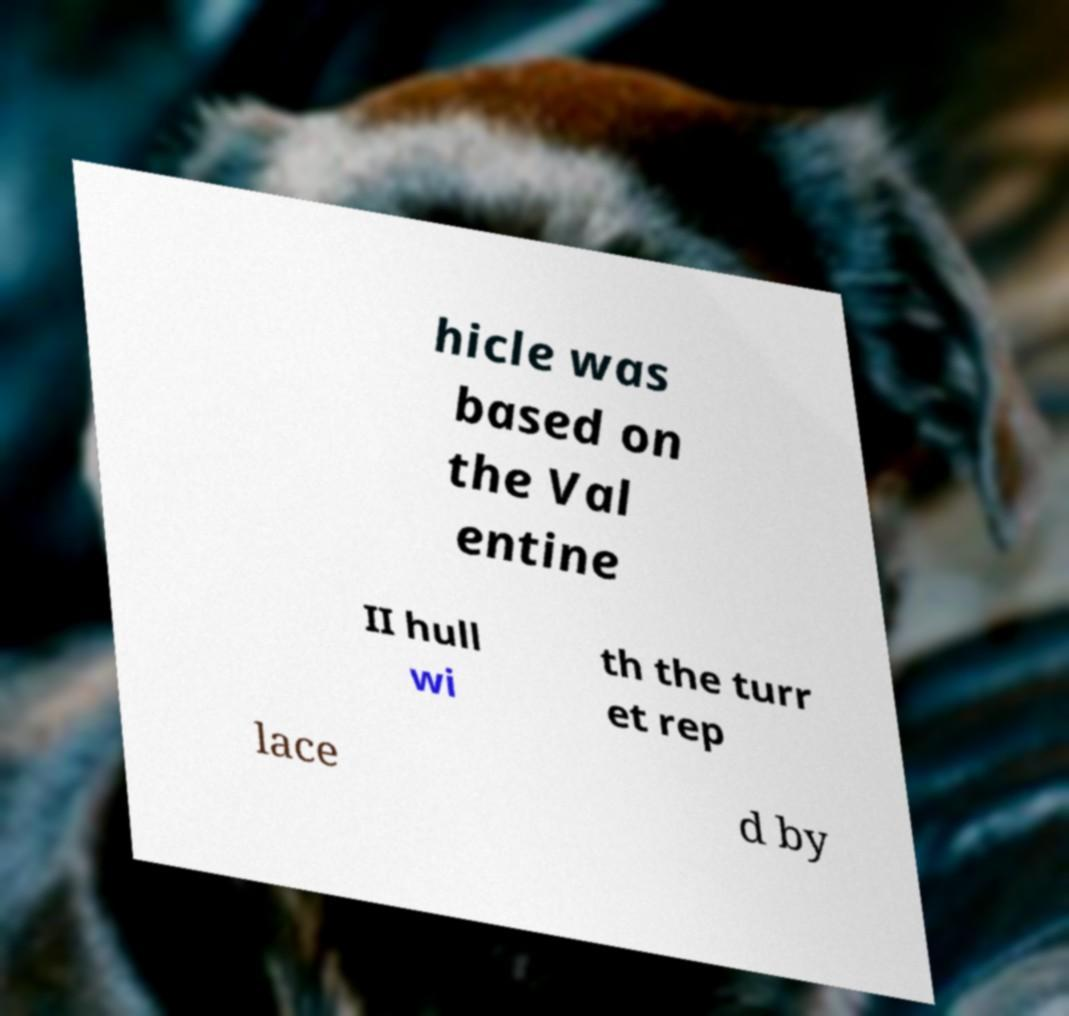Can you accurately transcribe the text from the provided image for me? hicle was based on the Val entine II hull wi th the turr et rep lace d by 